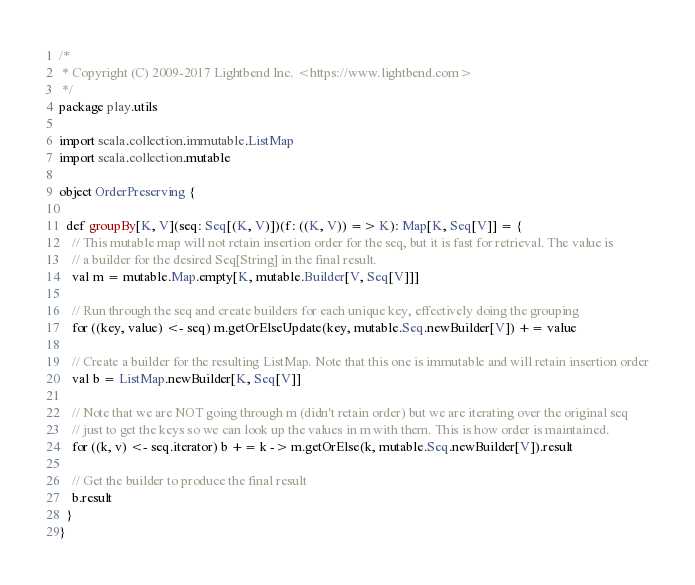Convert code to text. <code><loc_0><loc_0><loc_500><loc_500><_Scala_>/*
 * Copyright (C) 2009-2017 Lightbend Inc. <https://www.lightbend.com>
 */
package play.utils

import scala.collection.immutable.ListMap
import scala.collection.mutable

object OrderPreserving {

  def groupBy[K, V](seq: Seq[(K, V)])(f: ((K, V)) => K): Map[K, Seq[V]] = {
    // This mutable map will not retain insertion order for the seq, but it is fast for retrieval. The value is
    // a builder for the desired Seq[String] in the final result.
    val m = mutable.Map.empty[K, mutable.Builder[V, Seq[V]]]

    // Run through the seq and create builders for each unique key, effectively doing the grouping
    for ((key, value) <- seq) m.getOrElseUpdate(key, mutable.Seq.newBuilder[V]) += value

    // Create a builder for the resulting ListMap. Note that this one is immutable and will retain insertion order
    val b = ListMap.newBuilder[K, Seq[V]]

    // Note that we are NOT going through m (didn't retain order) but we are iterating over the original seq
    // just to get the keys so we can look up the values in m with them. This is how order is maintained.
    for ((k, v) <- seq.iterator) b += k -> m.getOrElse(k, mutable.Seq.newBuilder[V]).result

    // Get the builder to produce the final result
    b.result
  }
}
</code> 